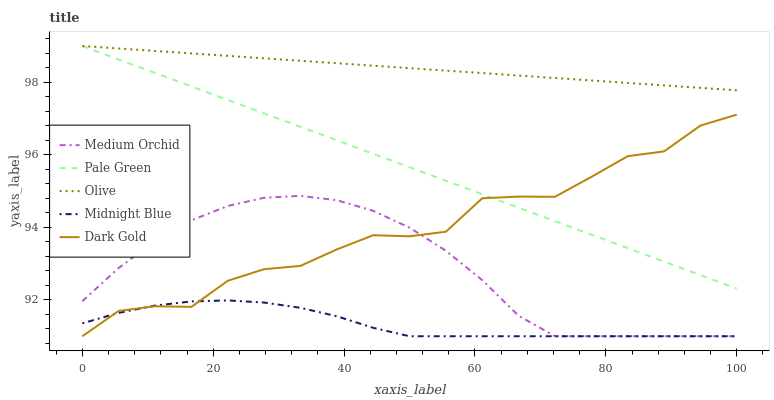Does Midnight Blue have the minimum area under the curve?
Answer yes or no. Yes. Does Olive have the maximum area under the curve?
Answer yes or no. Yes. Does Pale Green have the minimum area under the curve?
Answer yes or no. No. Does Pale Green have the maximum area under the curve?
Answer yes or no. No. Is Olive the smoothest?
Answer yes or no. Yes. Is Dark Gold the roughest?
Answer yes or no. Yes. Is Pale Green the smoothest?
Answer yes or no. No. Is Pale Green the roughest?
Answer yes or no. No. Does Medium Orchid have the lowest value?
Answer yes or no. Yes. Does Pale Green have the lowest value?
Answer yes or no. No. Does Pale Green have the highest value?
Answer yes or no. Yes. Does Medium Orchid have the highest value?
Answer yes or no. No. Is Dark Gold less than Olive?
Answer yes or no. Yes. Is Olive greater than Medium Orchid?
Answer yes or no. Yes. Does Medium Orchid intersect Midnight Blue?
Answer yes or no. Yes. Is Medium Orchid less than Midnight Blue?
Answer yes or no. No. Is Medium Orchid greater than Midnight Blue?
Answer yes or no. No. Does Dark Gold intersect Olive?
Answer yes or no. No. 